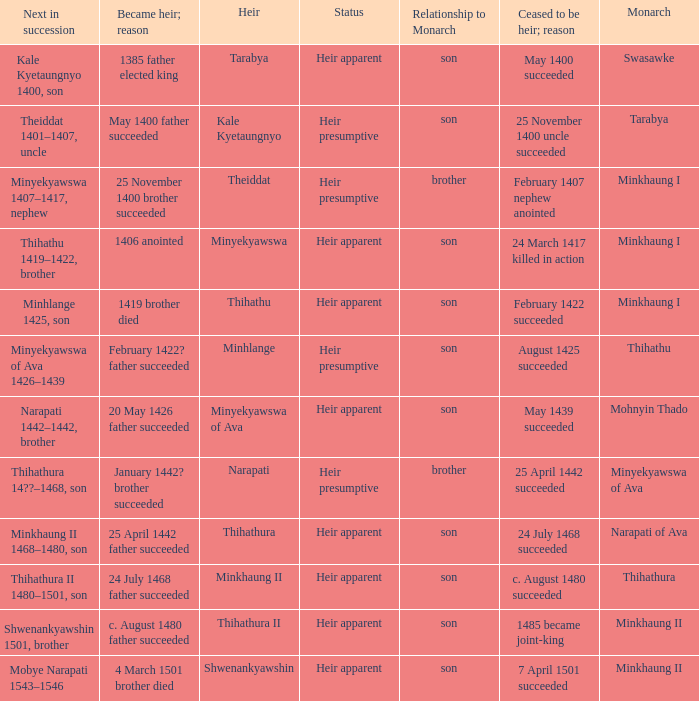How many reasons did the son and heir Kale Kyetaungnyo has when he ceased to be heir? 1.0. 